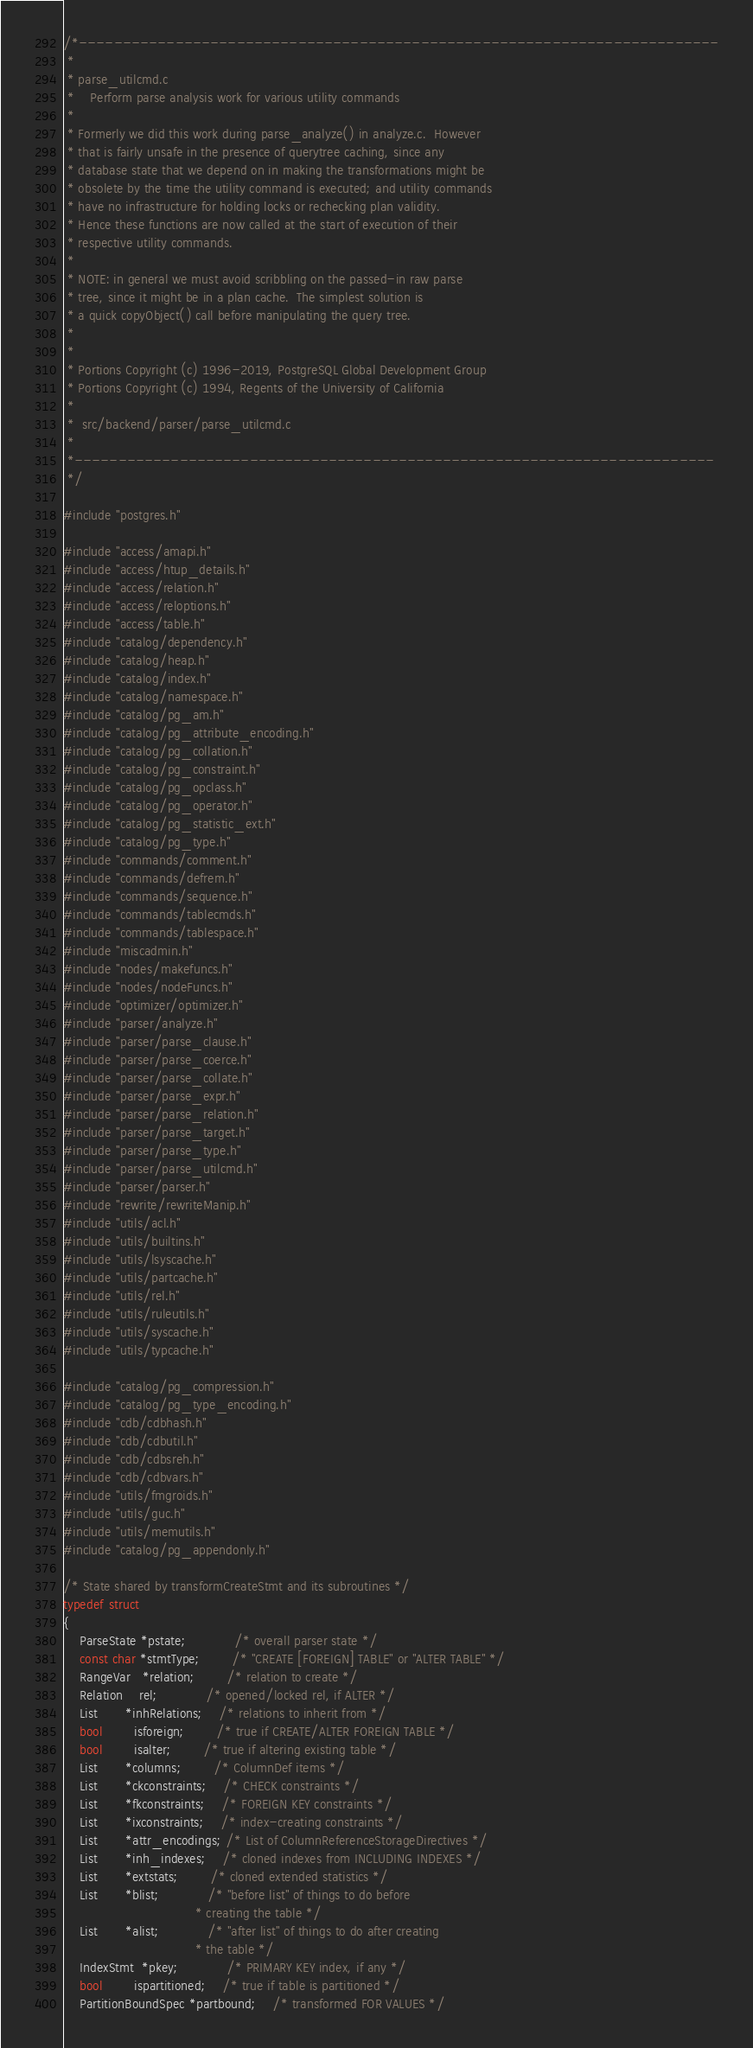<code> <loc_0><loc_0><loc_500><loc_500><_C_>/*-------------------------------------------------------------------------
 *
 * parse_utilcmd.c
 *	  Perform parse analysis work for various utility commands
 *
 * Formerly we did this work during parse_analyze() in analyze.c.  However
 * that is fairly unsafe in the presence of querytree caching, since any
 * database state that we depend on in making the transformations might be
 * obsolete by the time the utility command is executed; and utility commands
 * have no infrastructure for holding locks or rechecking plan validity.
 * Hence these functions are now called at the start of execution of their
 * respective utility commands.
 *
 * NOTE: in general we must avoid scribbling on the passed-in raw parse
 * tree, since it might be in a plan cache.  The simplest solution is
 * a quick copyObject() call before manipulating the query tree.
 *
 *
 * Portions Copyright (c) 1996-2019, PostgreSQL Global Development Group
 * Portions Copyright (c) 1994, Regents of the University of California
 *
 *	src/backend/parser/parse_utilcmd.c
 *
 *-------------------------------------------------------------------------
 */

#include "postgres.h"

#include "access/amapi.h"
#include "access/htup_details.h"
#include "access/relation.h"
#include "access/reloptions.h"
#include "access/table.h"
#include "catalog/dependency.h"
#include "catalog/heap.h"
#include "catalog/index.h"
#include "catalog/namespace.h"
#include "catalog/pg_am.h"
#include "catalog/pg_attribute_encoding.h"
#include "catalog/pg_collation.h"
#include "catalog/pg_constraint.h"
#include "catalog/pg_opclass.h"
#include "catalog/pg_operator.h"
#include "catalog/pg_statistic_ext.h"
#include "catalog/pg_type.h"
#include "commands/comment.h"
#include "commands/defrem.h"
#include "commands/sequence.h"
#include "commands/tablecmds.h"
#include "commands/tablespace.h"
#include "miscadmin.h"
#include "nodes/makefuncs.h"
#include "nodes/nodeFuncs.h"
#include "optimizer/optimizer.h"
#include "parser/analyze.h"
#include "parser/parse_clause.h"
#include "parser/parse_coerce.h"
#include "parser/parse_collate.h"
#include "parser/parse_expr.h"
#include "parser/parse_relation.h"
#include "parser/parse_target.h"
#include "parser/parse_type.h"
#include "parser/parse_utilcmd.h"
#include "parser/parser.h"
#include "rewrite/rewriteManip.h"
#include "utils/acl.h"
#include "utils/builtins.h"
#include "utils/lsyscache.h"
#include "utils/partcache.h"
#include "utils/rel.h"
#include "utils/ruleutils.h"
#include "utils/syscache.h"
#include "utils/typcache.h"

#include "catalog/pg_compression.h"
#include "catalog/pg_type_encoding.h"
#include "cdb/cdbhash.h"
#include "cdb/cdbutil.h"
#include "cdb/cdbsreh.h"
#include "cdb/cdbvars.h"
#include "utils/fmgroids.h"
#include "utils/guc.h"
#include "utils/memutils.h"
#include "catalog/pg_appendonly.h"

/* State shared by transformCreateStmt and its subroutines */
typedef struct
{
	ParseState *pstate;			/* overall parser state */
	const char *stmtType;		/* "CREATE [FOREIGN] TABLE" or "ALTER TABLE" */
	RangeVar   *relation;		/* relation to create */
	Relation	rel;			/* opened/locked rel, if ALTER */
	List	   *inhRelations;	/* relations to inherit from */
	bool		isforeign;		/* true if CREATE/ALTER FOREIGN TABLE */
	bool		isalter;		/* true if altering existing table */
	List	   *columns;		/* ColumnDef items */
	List	   *ckconstraints;	/* CHECK constraints */
	List	   *fkconstraints;	/* FOREIGN KEY constraints */
	List	   *ixconstraints;	/* index-creating constraints */
	List	   *attr_encodings; /* List of ColumnReferenceStorageDirectives */
	List	   *inh_indexes;	/* cloned indexes from INCLUDING INDEXES */
	List	   *extstats;		/* cloned extended statistics */
	List	   *blist;			/* "before list" of things to do before
								 * creating the table */
	List	   *alist;			/* "after list" of things to do after creating
								 * the table */
	IndexStmt  *pkey;			/* PRIMARY KEY index, if any */
	bool		ispartitioned;	/* true if table is partitioned */
	PartitionBoundSpec *partbound;	/* transformed FOR VALUES */</code> 